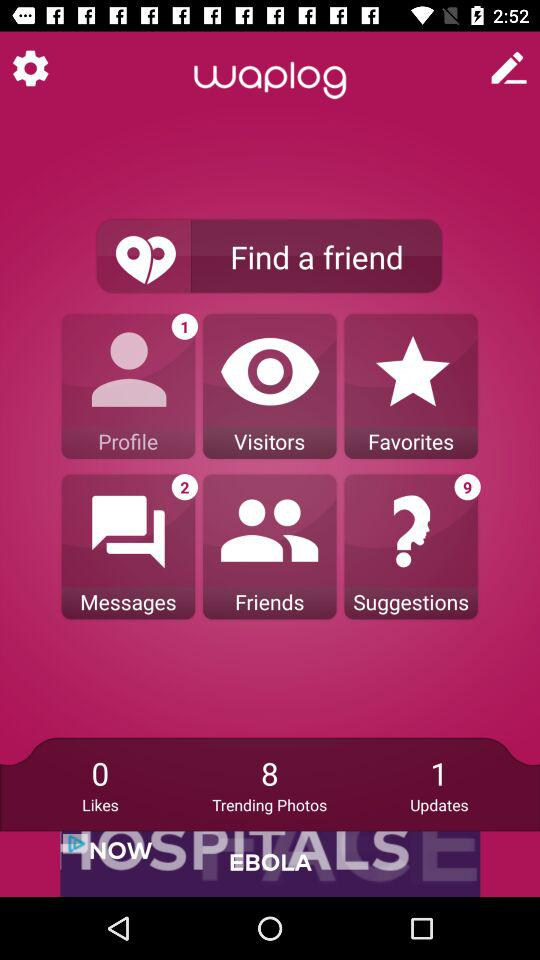What is the name of the application? The name of the application is "waplog". 